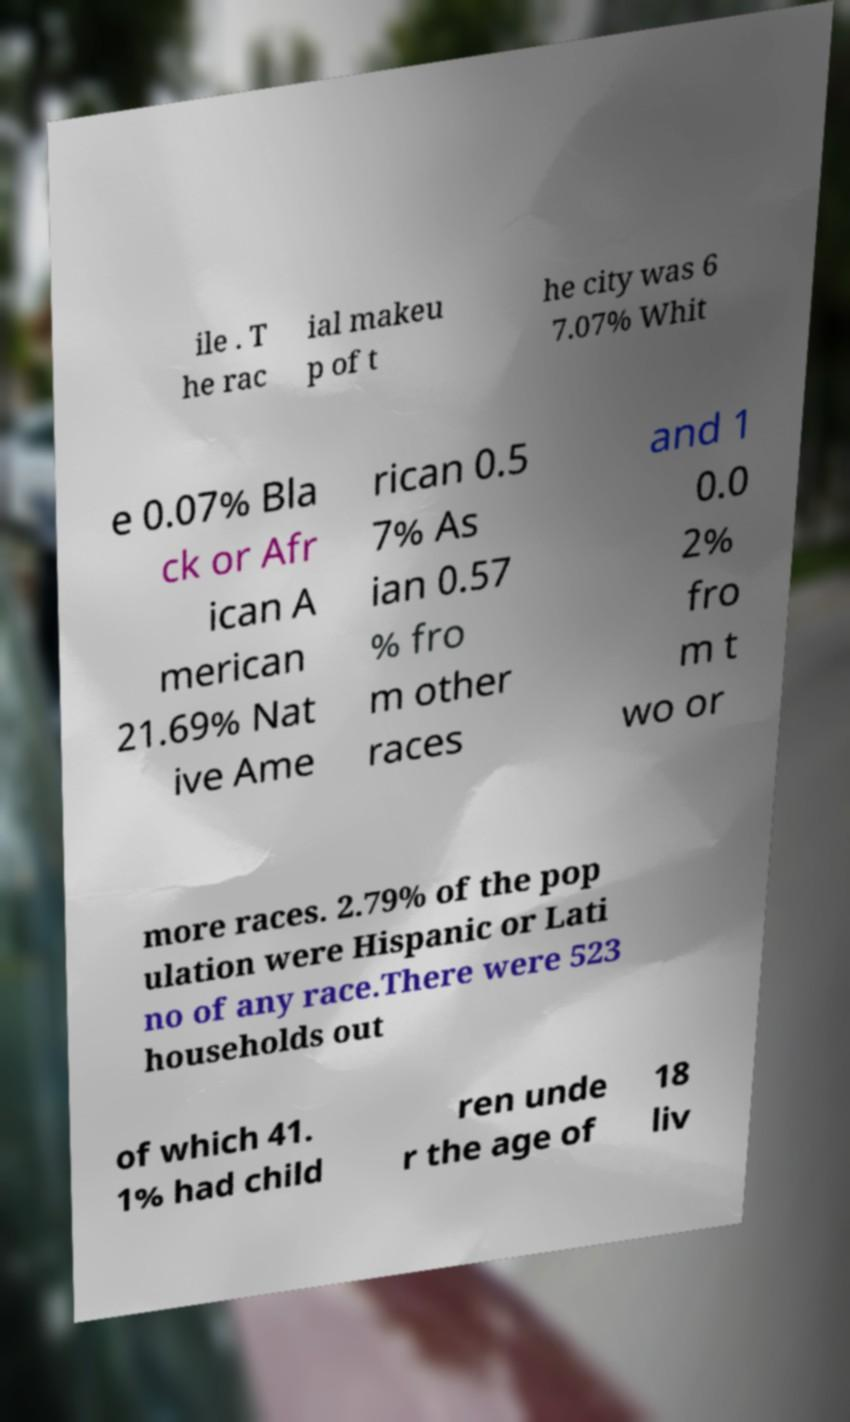I need the written content from this picture converted into text. Can you do that? ile . T he rac ial makeu p of t he city was 6 7.07% Whit e 0.07% Bla ck or Afr ican A merican 21.69% Nat ive Ame rican 0.5 7% As ian 0.57 % fro m other races and 1 0.0 2% fro m t wo or more races. 2.79% of the pop ulation were Hispanic or Lati no of any race.There were 523 households out of which 41. 1% had child ren unde r the age of 18 liv 